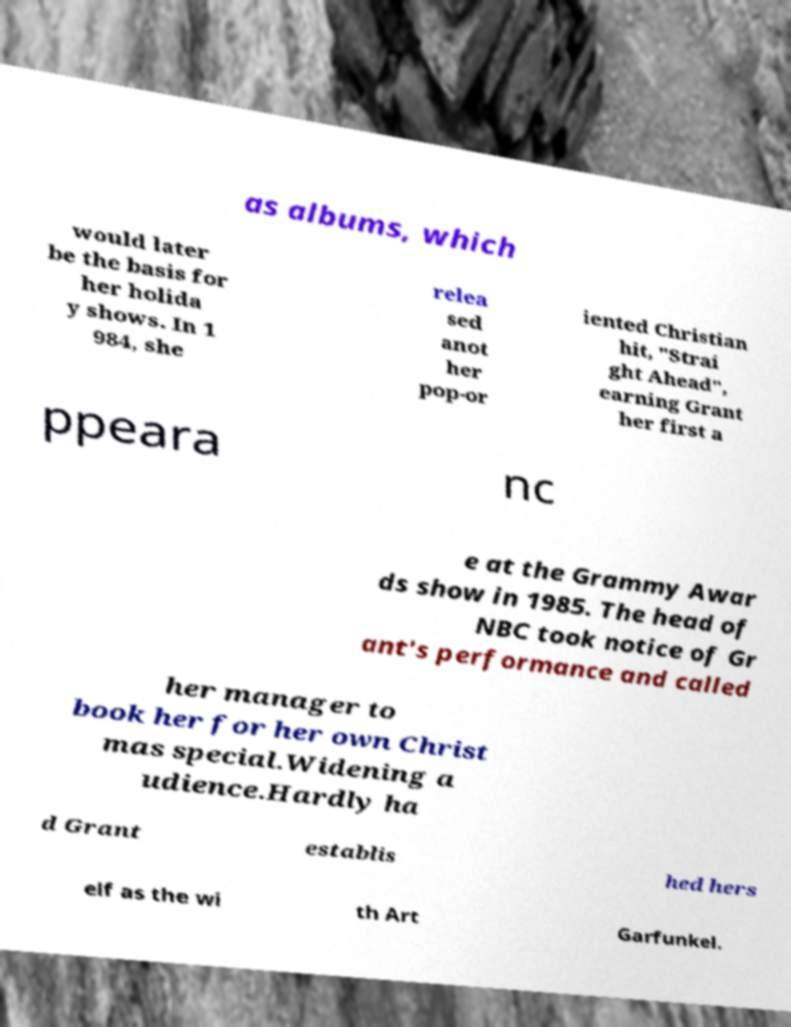What messages or text are displayed in this image? I need them in a readable, typed format. as albums, which would later be the basis for her holida y shows. In 1 984, she relea sed anot her pop-or iented Christian hit, "Strai ght Ahead", earning Grant her first a ppeara nc e at the Grammy Awar ds show in 1985. The head of NBC took notice of Gr ant's performance and called her manager to book her for her own Christ mas special.Widening a udience.Hardly ha d Grant establis hed hers elf as the wi th Art Garfunkel. 